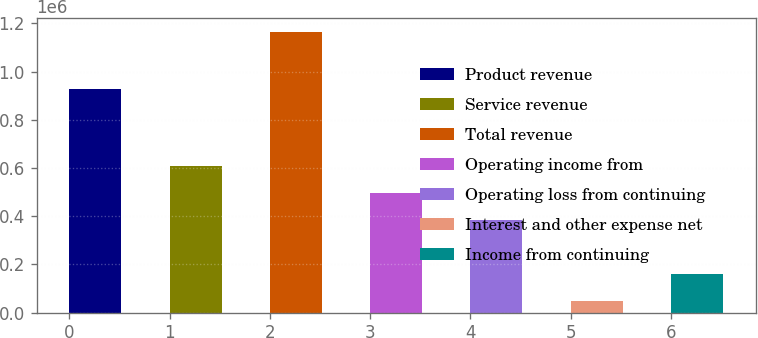Convert chart to OTSL. <chart><loc_0><loc_0><loc_500><loc_500><bar_chart><fcel>Product revenue<fcel>Service revenue<fcel>Total revenue<fcel>Operating income from<fcel>Operating loss from continuing<fcel>Interest and other expense net<fcel>Income from continuing<nl><fcel>926733<fcel>606290<fcel>1.16462e+06<fcel>494624<fcel>382957<fcel>47956<fcel>159623<nl></chart> 